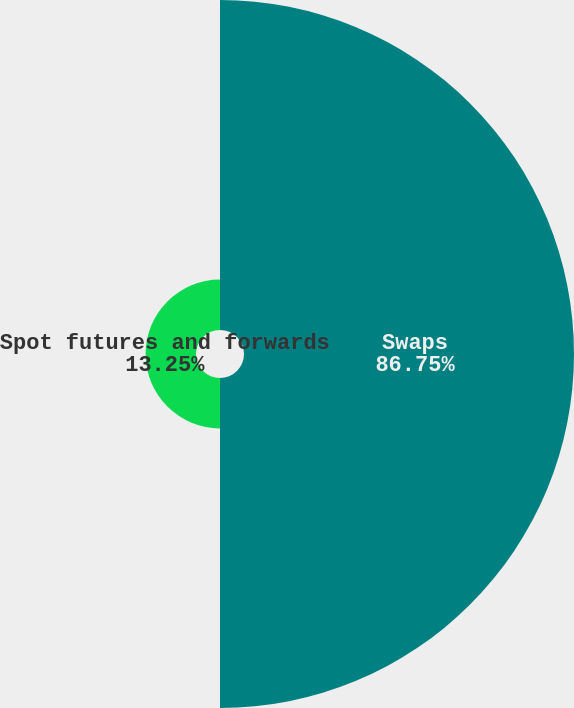Convert chart. <chart><loc_0><loc_0><loc_500><loc_500><pie_chart><fcel>Swaps<fcel>Spot futures and forwards<nl><fcel>86.75%<fcel>13.25%<nl></chart> 